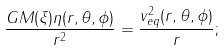<formula> <loc_0><loc_0><loc_500><loc_500>\frac { G M ( \xi ) \eta ( r , \theta , \phi ) } { r ^ { 2 } } = \frac { v _ { e q } ^ { 2 } ( r , \theta , \phi ) } r ;</formula> 